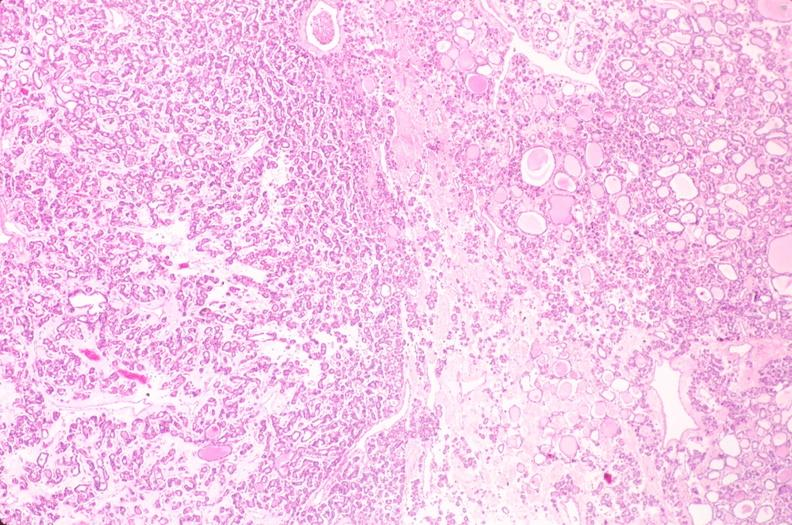what is present?
Answer the question using a single word or phrase. Endocrine 